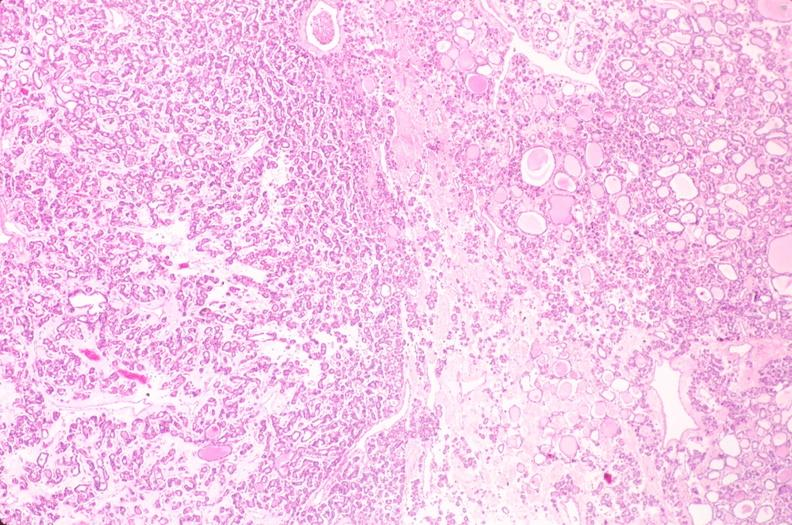what is present?
Answer the question using a single word or phrase. Endocrine 